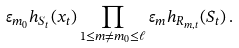Convert formula to latex. <formula><loc_0><loc_0><loc_500><loc_500>\varepsilon _ { m _ { 0 } } h _ { S _ { t } } ( x _ { t } ) \prod _ { 1 \leq m \neq m _ { 0 } \leq \ell } \varepsilon _ { m } h _ { R _ { m , t } } ( S _ { t } ) \, .</formula> 